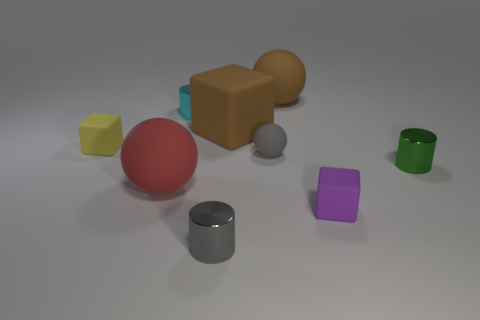Is the color of the large rubber cube the same as the tiny ball?
Make the answer very short. No. How many matte things are either large brown objects or tiny brown things?
Your answer should be compact. 2. How many large cyan spheres are there?
Your response must be concise. 0. Is the material of the small cube that is behind the large red rubber ball the same as the small gray thing behind the gray metallic cylinder?
Ensure brevity in your answer.  Yes. What is the color of the large thing that is the same shape as the small yellow rubber object?
Keep it short and to the point. Brown. What is the material of the brown thing behind the brown matte block on the right side of the big red object?
Offer a terse response. Rubber. There is a small thing that is in front of the small purple matte thing; is it the same shape as the small gray thing behind the tiny purple object?
Make the answer very short. No. What size is the cube that is left of the brown sphere and to the right of the yellow rubber cube?
Your answer should be very brief. Large. What number of other things are the same color as the big matte cube?
Your answer should be very brief. 1. Is the material of the sphere behind the small cyan object the same as the yellow thing?
Ensure brevity in your answer.  Yes. 